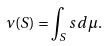<formula> <loc_0><loc_0><loc_500><loc_500>\nu ( S ) = \int _ { S } s \, d \mu .</formula> 